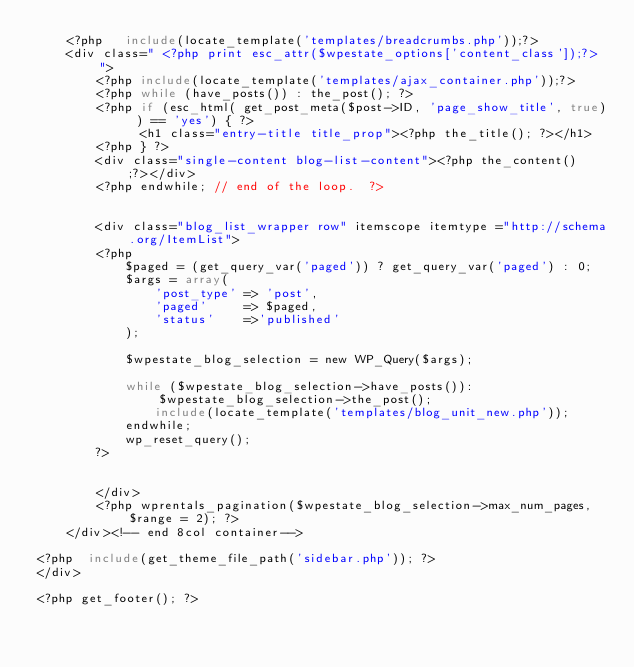Convert code to text. <code><loc_0><loc_0><loc_500><loc_500><_PHP_>    <?php   include(locate_template('templates/breadcrumbs.php'));?>
    <div class=" <?php print esc_attr($wpestate_options['content_class']);?> ">
        <?php include(locate_template('templates/ajax_container.php'));?>
        <?php while (have_posts()) : the_post(); ?>
        <?php if (esc_html( get_post_meta($post->ID, 'page_show_title', true) ) == 'yes') { ?>
              <h1 class="entry-title title_prop"><?php the_title(); ?></h1>
        <?php } ?>
        <div class="single-content blog-list-content"><?php the_content();?></div>   
        <?php endwhile; // end of the loop.  ?>  

              
        <div class="blog_list_wrapper row" itemscope itemtype ="http://schema.org/ItemList">    
        <?php
            $paged = (get_query_var('paged')) ? get_query_var('paged') : 0;
            $args = array(
                'post_type' => 'post',
                'paged'     => $paged,
                'status'    =>'published'
            );

            $wpestate_blog_selection = new WP_Query($args);
            
            while ($wpestate_blog_selection->have_posts()): $wpestate_blog_selection->the_post();
                include(locate_template('templates/blog_unit_new.php'));
            endwhile;
            wp_reset_query();
        ?>
        
           
        </div>
        <?php wprentals_pagination($wpestate_blog_selection->max_num_pages, $range = 2); ?>    
    </div><!-- end 8col container-->
    
<?php  include(get_theme_file_path('sidebar.php')); ?>
</div>   

<?php get_footer(); ?></code> 